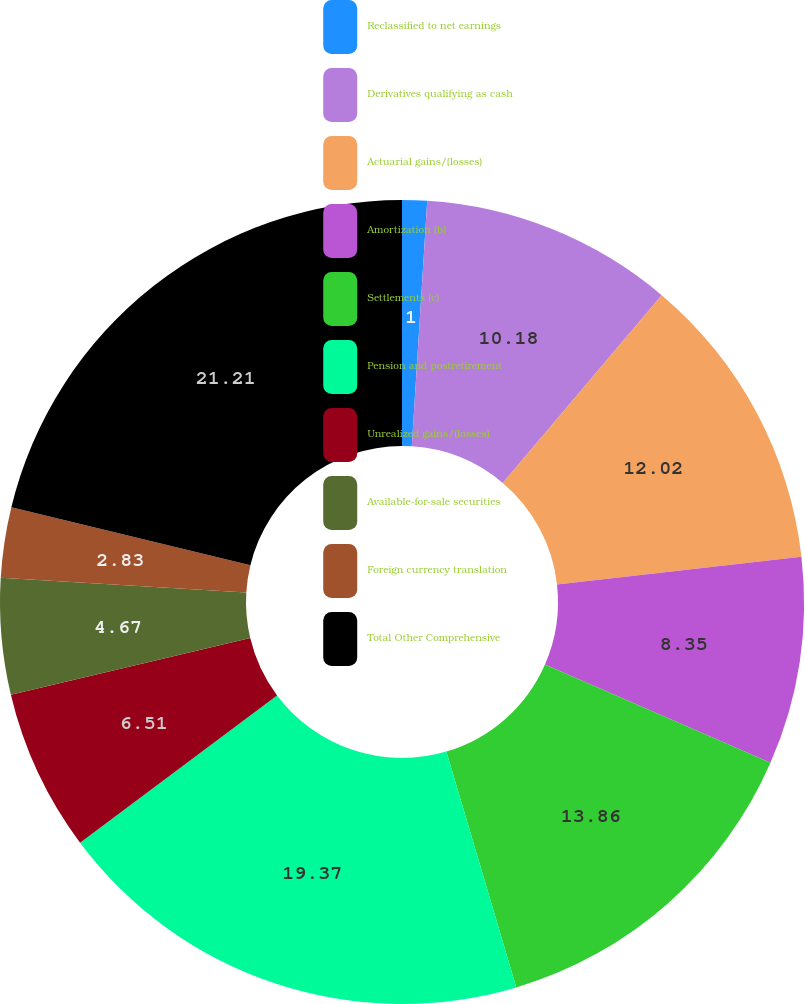Convert chart. <chart><loc_0><loc_0><loc_500><loc_500><pie_chart><fcel>Reclassified to net earnings<fcel>Derivatives qualifying as cash<fcel>Actuarial gains/(losses)<fcel>Amortization (b)<fcel>Settlements (c)<fcel>Pension and postretirement<fcel>Unrealized gains/(losses)<fcel>Available-for-sale securities<fcel>Foreign currency translation<fcel>Total Other Comprehensive<nl><fcel>1.0%<fcel>10.18%<fcel>12.02%<fcel>8.35%<fcel>13.86%<fcel>19.37%<fcel>6.51%<fcel>4.67%<fcel>2.83%<fcel>21.21%<nl></chart> 